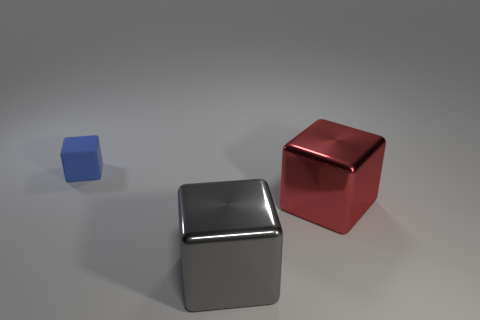Subtract all tiny blue blocks. How many blocks are left? 2 Add 2 metal objects. How many objects exist? 5 Subtract all blue blocks. How many blocks are left? 2 Subtract 0 cyan blocks. How many objects are left? 3 Subtract 2 cubes. How many cubes are left? 1 Subtract all yellow cubes. Subtract all gray cylinders. How many cubes are left? 3 Subtract all yellow spheres. How many red blocks are left? 1 Subtract all large gray metallic blocks. Subtract all tiny blue rubber cubes. How many objects are left? 1 Add 2 red shiny cubes. How many red shiny cubes are left? 3 Add 3 big red shiny objects. How many big red shiny objects exist? 4 